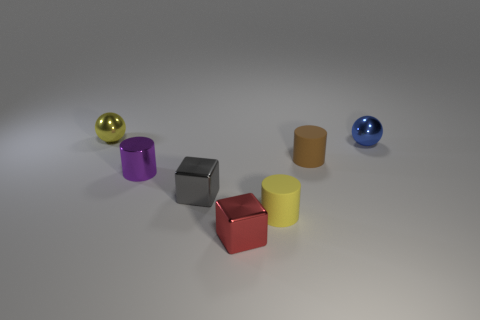Add 3 brown shiny blocks. How many objects exist? 10 Subtract all cylinders. How many objects are left? 4 Add 3 small blue metal balls. How many small blue metal balls exist? 4 Subtract 0 purple spheres. How many objects are left? 7 Subtract all small cyan objects. Subtract all tiny red things. How many objects are left? 6 Add 7 small red cubes. How many small red cubes are left? 8 